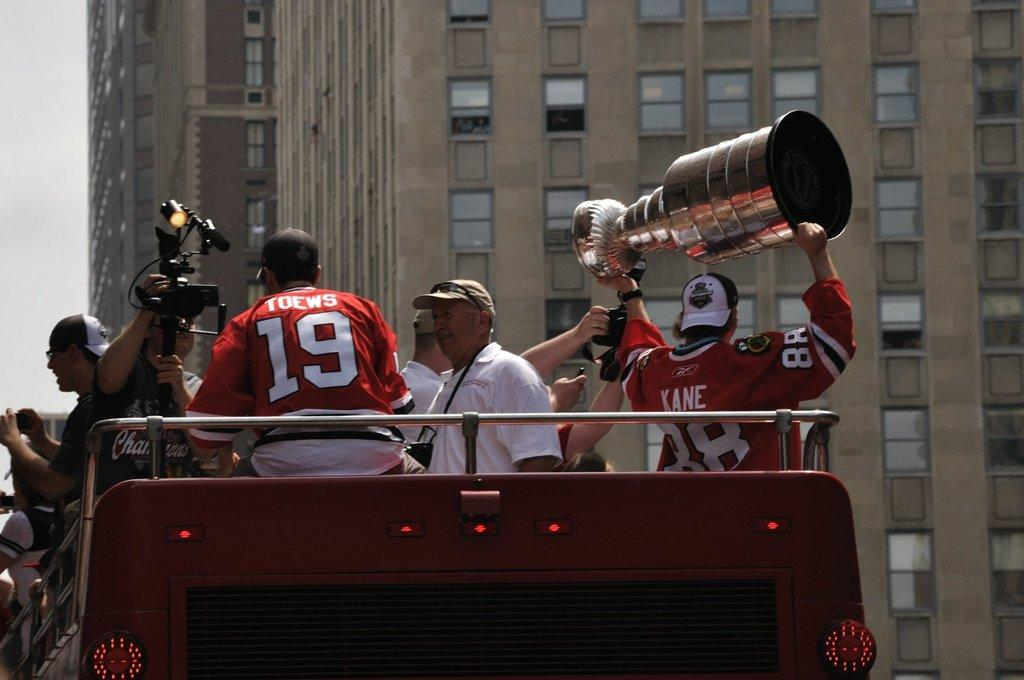<image>
Offer a succinct explanation of the picture presented. Man wearing a number 19 jersey sitting next to a man holding a trophy. 